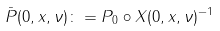<formula> <loc_0><loc_0><loc_500><loc_500>\bar { P } ( 0 , x , \nu ) \colon = P _ { 0 } \circ X ( 0 , x , \nu ) ^ { - 1 }</formula> 